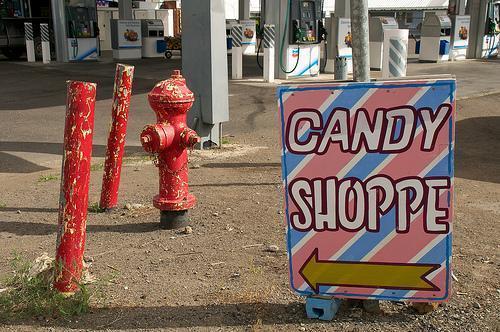How many fire hydrants are in the picture?
Give a very brief answer. 1. 